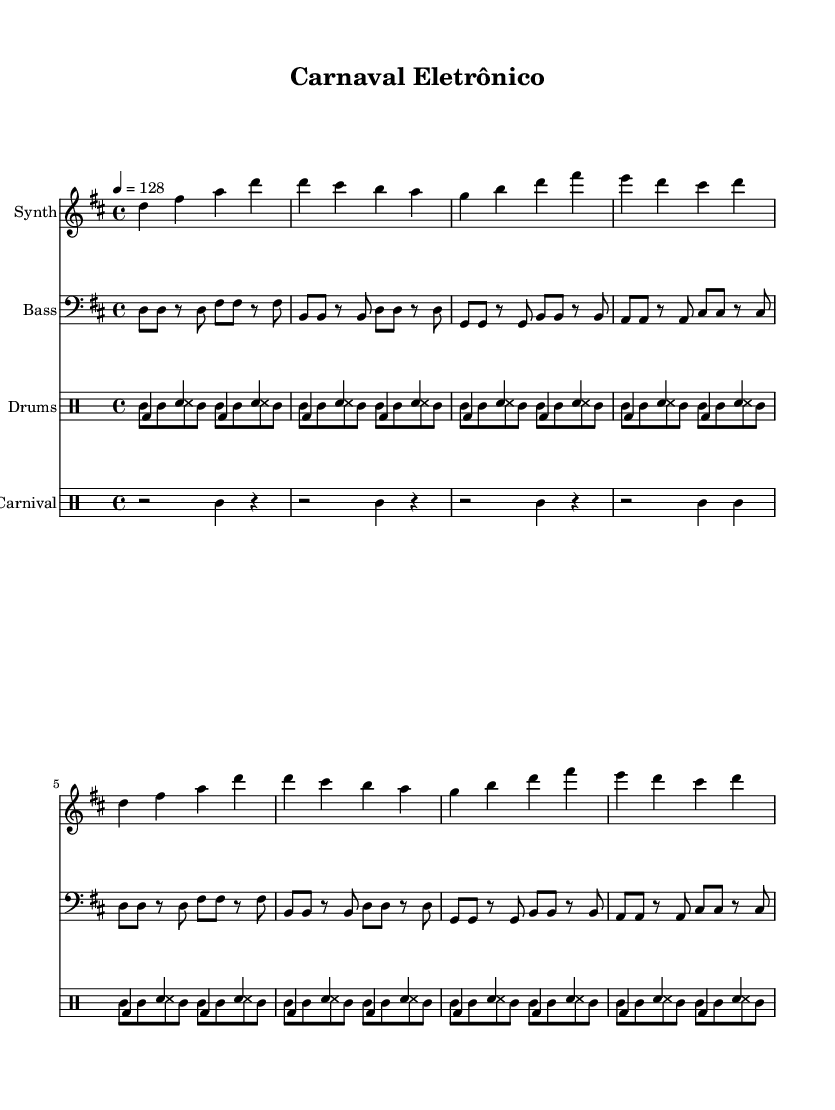What is the key signature of this music? The key signature is two sharps, D major. The presence of two sharps in the key signature indicates that the piece is in D major.
Answer: D major What is the time signature of the piece? The time signature is written as 4/4, which is indicated at the beginning of the score. This means there are four beats in a measure and the quarter note gets one beat.
Answer: 4/4 What is the tempo marking for this music? The tempo marking is given as 4 = 128, which suggests the piece should be played at 128 beats per minute using a quarter note as the beat unit.
Answer: 128 How many measures are in the synthesizer part? The synthesizer part contains 16 measures. This can be determined by counting the repeated sections, with 2 repeats of 4 measures each, resulting in a total of 16.
Answer: 16 Which instruments are involved in the percussion section? The percussion section includes a traditional drum machine and samba drums, categorized under two separate drum voices within the score. This is indicated by the specific rhythmic patterns written for each.
Answer: Drum machine, samba drums What is the unique rhythmic element of the samba drums? The unique rhythmic element of the samba drums is the use of a tambourine pattern featuring 8 notes with specific stress and rhythm, which emphasizes the samba genre.
Answer: Tambourine pattern What type of sounds are included in the carnival section? The carnival section features carnival sounds such as wbh and rests, which add a festive character to the music, reflecting the atmosphere of a Brazilian carnival.
Answer: Carnival sounds 